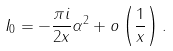Convert formula to latex. <formula><loc_0><loc_0><loc_500><loc_500>I _ { 0 } = - \frac { \pi i } { 2 x } \alpha ^ { 2 } + o \left ( \frac { 1 } { x } \right ) .</formula> 